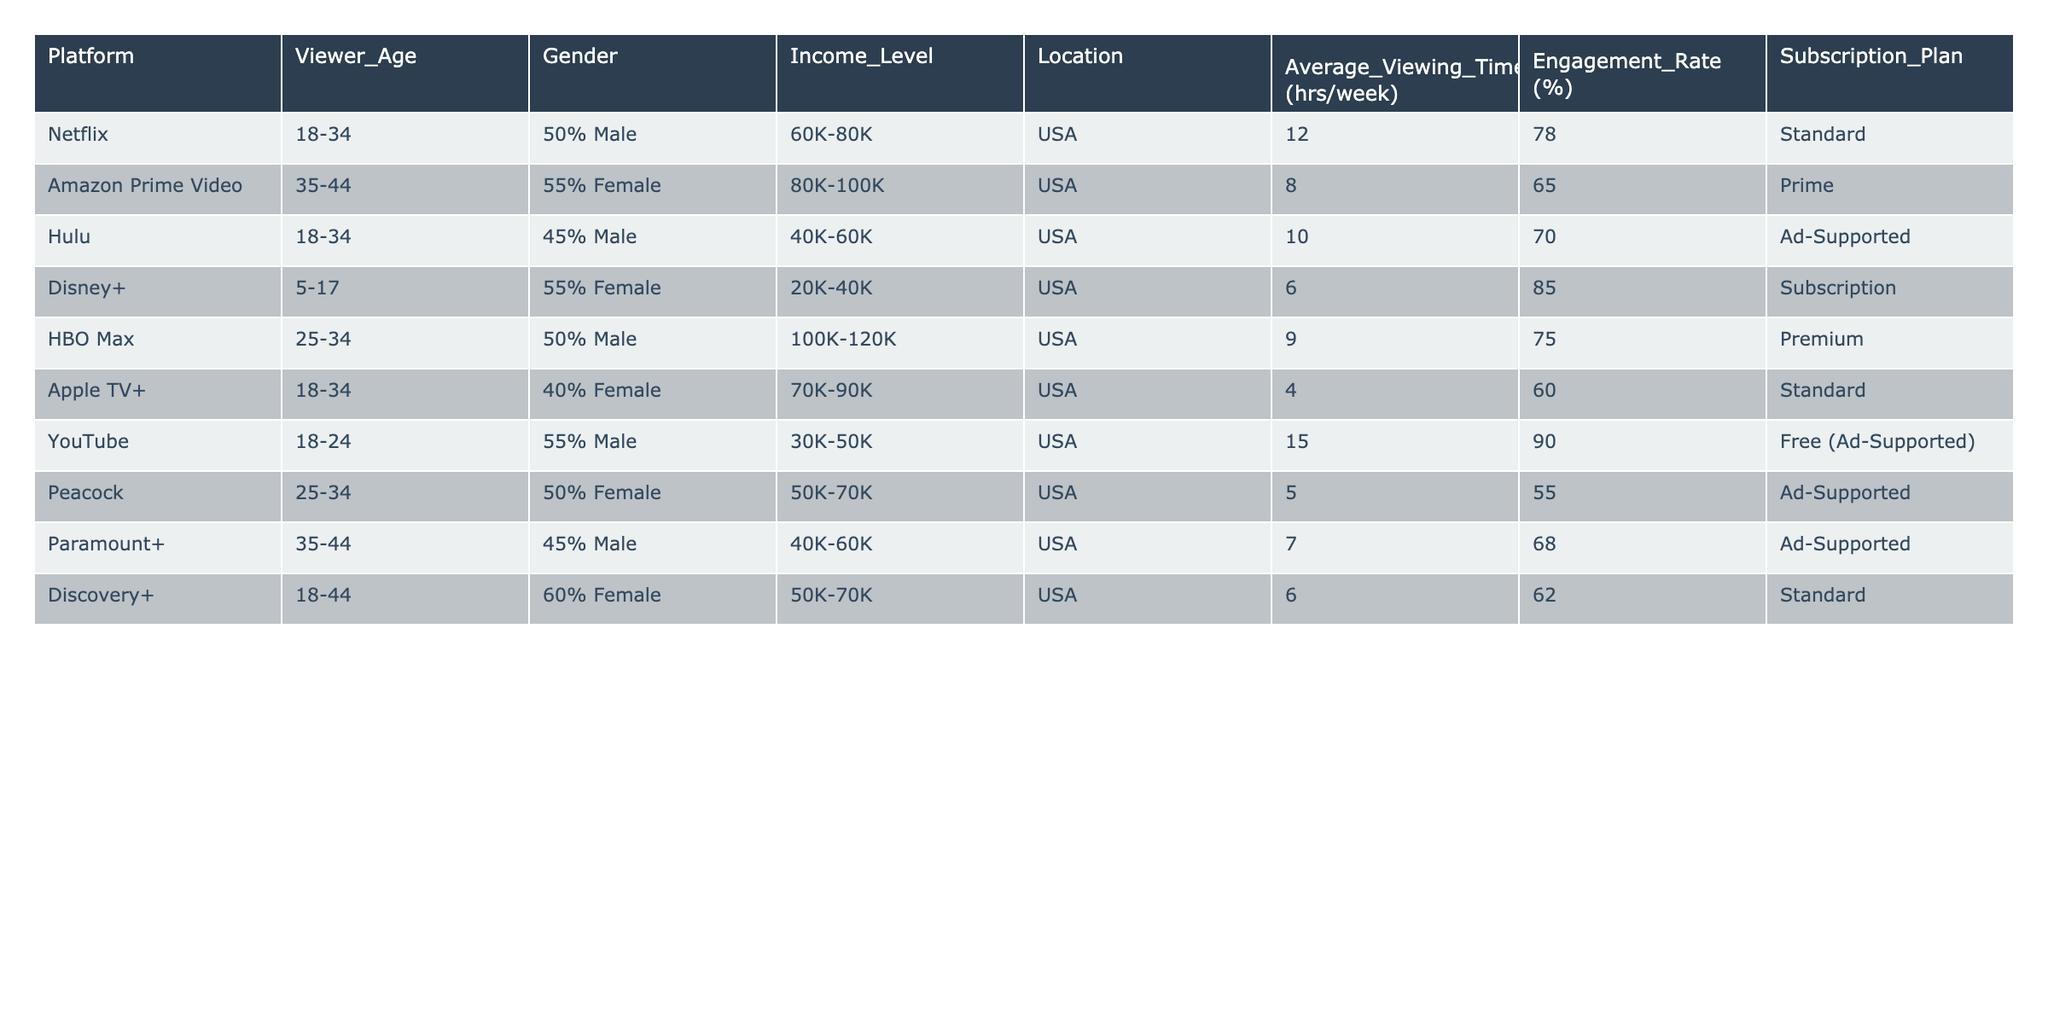What platform has the highest average viewing time per week? By examining the 'Average Viewing Time (hrs/week)' column, we see that YouTube has the highest value at 15 hours per week compared to other platforms.
Answer: YouTube Which platform has the lowest engagement rate? Looking at the 'Engagement Rate (%)' column, Peacock has the lowest engagement rate at 55%.
Answer: Peacock What is the age range of viewers for Disney+? The table clearly indicates that the age range of viewers for Disney+ is 5-17.
Answer: 5-17 Is there a platform that offers a free subscription plan? The table shows YouTube as the only platform with a free subscription plan, confirming that this statement is true.
Answer: Yes Calculate the average income level of platforms targeting the 18-34 age group. The platforms targeting this age group are Netflix, Hulu, and Apple TV+. Their income levels are: 60K-80K, 40K-60K, and 70K-90K. Averaging these income ranges, we find the midpoint of each: 70K, 50K, 80K. Summing these gives 200K, and dividing by 3 results in an average income range of approximately 66.67K-76.67K.
Answer: 66.67K-76.67K List the proportion of male versus female viewers for HBO Max. The table indicates that HBO Max has 50% male viewers and does not specify female but is implicitly 50% female. This indicates an equal proportion.
Answer: 50% Male, 50% Female What is the average engagement rate for platforms with a subscription plan? The subscription platforms are Netflix, Amazon Prime Video, Disney+, HBO Max, Apple TV+, and Discovery+. Their engagement rates are 78%, 65%, 85%, 75%, 60%, and 62%. Adding these gives 425%, and dividing by 6 yields an average engagement rate of approximately 70.83%.
Answer: 70.83% Is it true that all platforms listed cater exclusively to the U.S. market? The data shows that all platforms are listed with 'USA' under the 'Location' column, thus confirming that they all cater exclusively to the U.S. market.
Answer: Yes Which platform has a higher average viewing time: Hulu or Peacock? According to the 'Average Viewing Time (hrs/week)' column, Hulu has an average of 10 hours while Peacock has an average of just 5 hours. Thus, Hulu has a higher average viewing time than Peacock.
Answer: Hulu What can be inferred about the target demographic for Discovery+ compared to Disney+? Discovery+ targets a broader age range (18-44) compared to Disney+, which targets a younger age group (5-17). This suggests that Discovery+ caters to a more mature audience than Disney+.
Answer: Discovery+ targets a broader demographic 